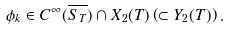Convert formula to latex. <formula><loc_0><loc_0><loc_500><loc_500>\phi _ { k } \in C ^ { \infty } ( \overline { S _ { T } } ) \cap X _ { 2 } ( T ) \left ( \subset Y _ { 2 } ( T ) \right ) .</formula> 